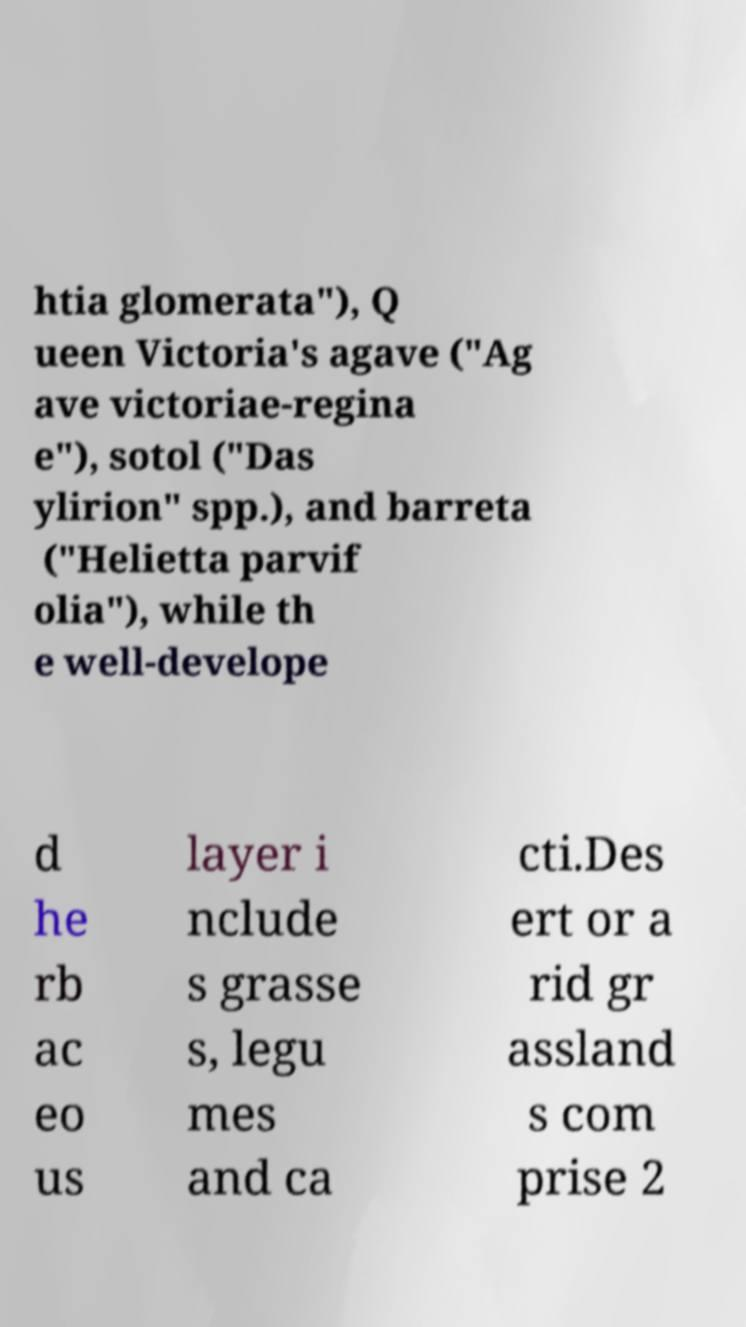I need the written content from this picture converted into text. Can you do that? htia glomerata"), Q ueen Victoria's agave ("Ag ave victoriae-regina e"), sotol ("Das ylirion" spp.), and barreta ("Helietta parvif olia"), while th e well-develope d he rb ac eo us layer i nclude s grasse s, legu mes and ca cti.Des ert or a rid gr assland s com prise 2 